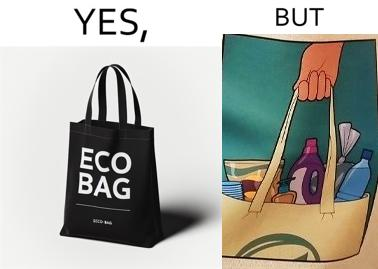What is shown in the left half versus the right half of this image? In the left part of the image: A picture of a bag with eco bag written on it. In the right part of the image: The image of the material that is kept in the bag. 